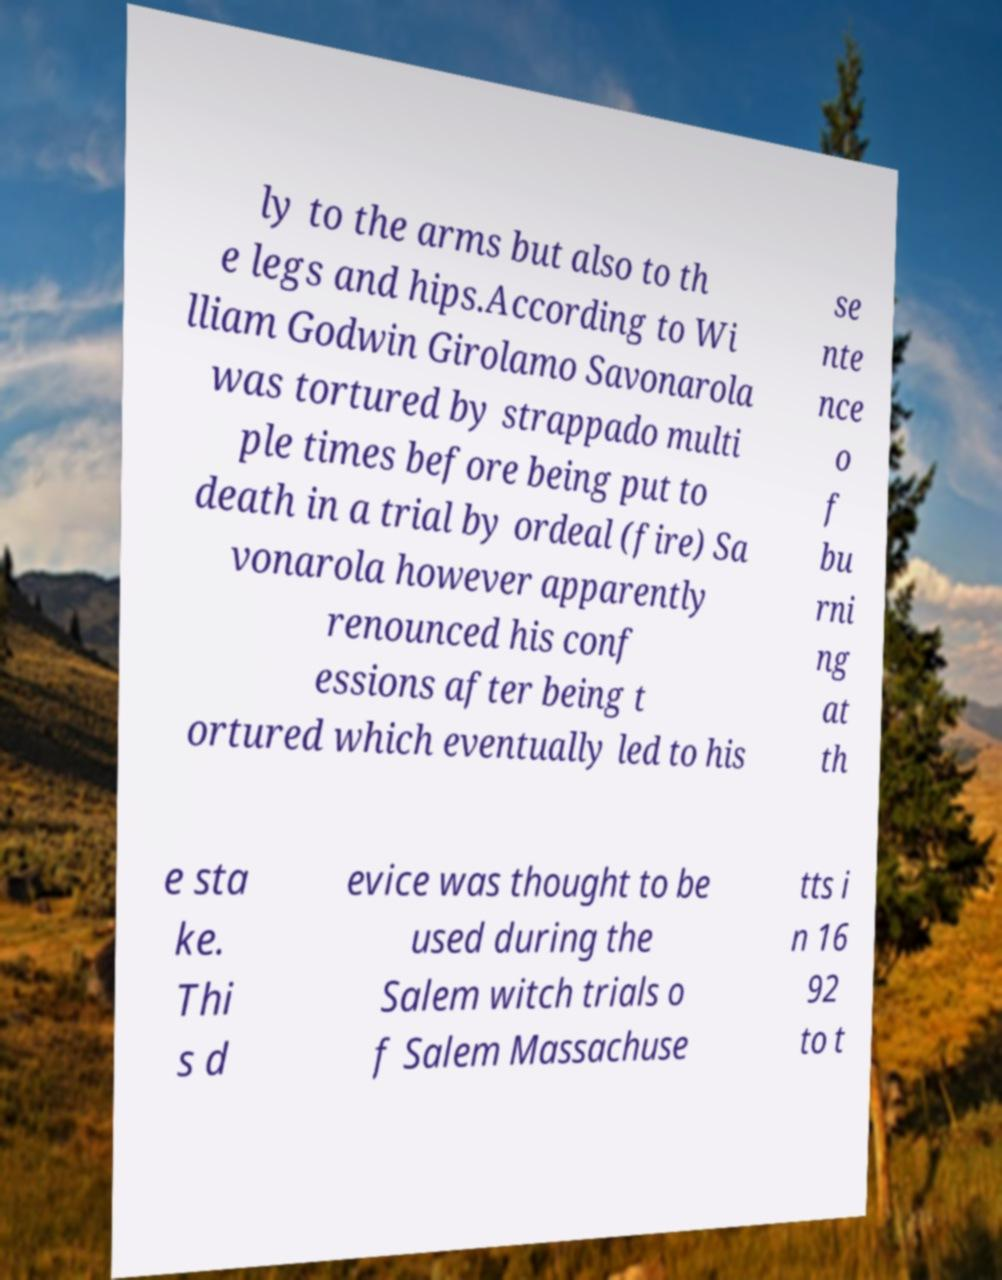I need the written content from this picture converted into text. Can you do that? ly to the arms but also to th e legs and hips.According to Wi lliam Godwin Girolamo Savonarola was tortured by strappado multi ple times before being put to death in a trial by ordeal (fire) Sa vonarola however apparently renounced his conf essions after being t ortured which eventually led to his se nte nce o f bu rni ng at th e sta ke. Thi s d evice was thought to be used during the Salem witch trials o f Salem Massachuse tts i n 16 92 to t 